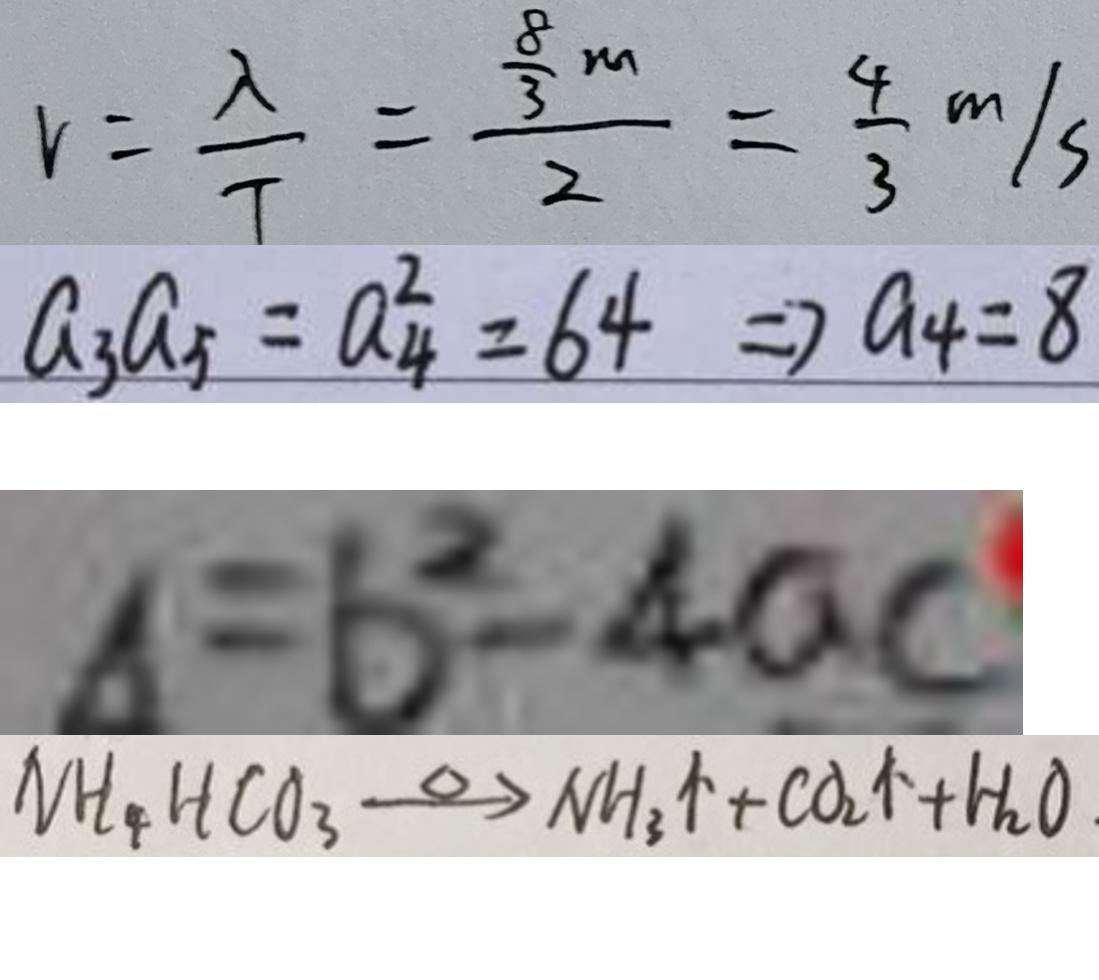<formula> <loc_0><loc_0><loc_500><loc_500>v = \frac { \lambda } { T } = \frac { \frac { 8 } { 3 } m } { 2 } = \frac { 4 } { 3 } m / s 
 a _ { 3 } a _ { 5 } = a _ { 4 } ^ { 2 } = 6 4 \Rightarrow a _ { 4 } = 8 
 \Delta = b ^ { 2 } - 4 a c 
 N H _ { 4 } H C O _ { 3 } \xrightarrow { \Delta } N H _ { 3 } \uparrow + C O _ { 2 } \uparrow + H _ { 2 } O</formula> 